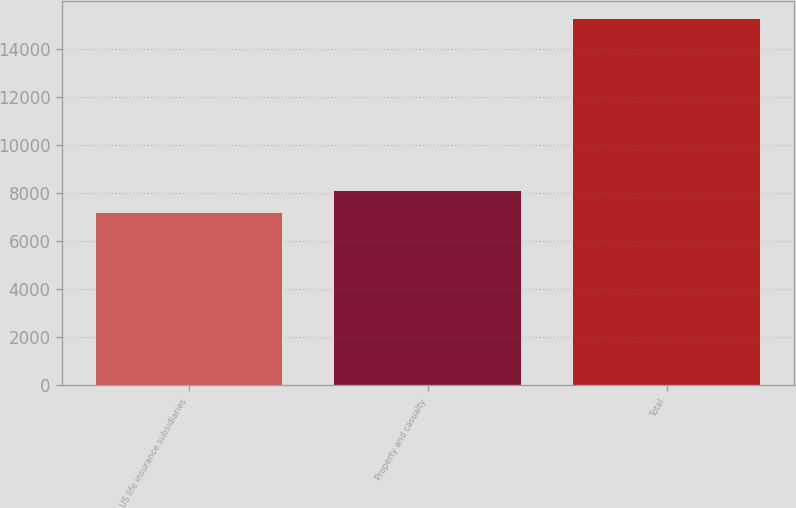Convert chart to OTSL. <chart><loc_0><loc_0><loc_500><loc_500><bar_chart><fcel>US life insurance subsidiaries<fcel>Property and casualty<fcel>Total<nl><fcel>7157<fcel>8069<fcel>15226<nl></chart> 